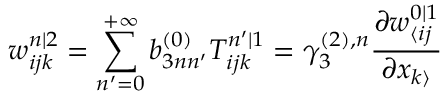Convert formula to latex. <formula><loc_0><loc_0><loc_500><loc_500>w _ { i j k } ^ { n | 2 } = \sum _ { n ^ { \prime } = 0 } ^ { + \infty } b _ { 3 n n ^ { \prime } } ^ { ( 0 ) } T _ { i j k } ^ { n ^ { \prime } | 1 } = \gamma _ { 3 } ^ { ( 2 ) , n } \frac { \partial w _ { \langle i j } ^ { 0 | 1 } } { \partial x _ { k \rangle } }</formula> 